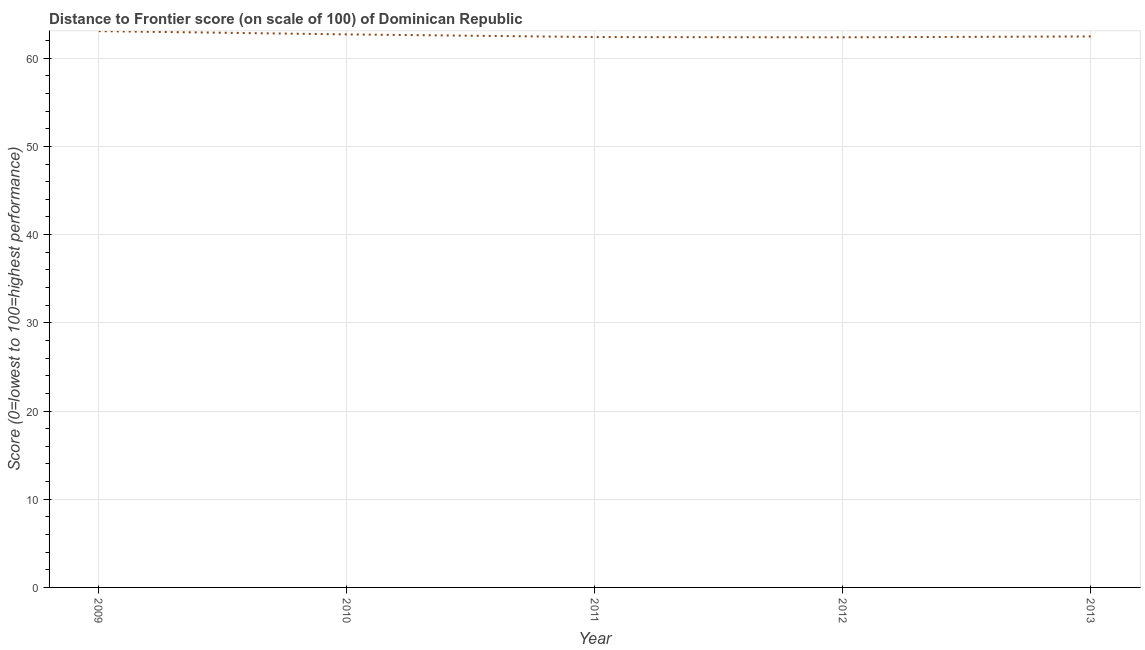What is the distance to frontier score in 2013?
Offer a terse response. 62.47. Across all years, what is the maximum distance to frontier score?
Offer a very short reply. 63.07. Across all years, what is the minimum distance to frontier score?
Offer a very short reply. 62.37. In which year was the distance to frontier score maximum?
Make the answer very short. 2009. What is the sum of the distance to frontier score?
Keep it short and to the point. 313.01. What is the difference between the distance to frontier score in 2010 and 2013?
Provide a short and direct response. 0.23. What is the average distance to frontier score per year?
Offer a very short reply. 62.6. What is the median distance to frontier score?
Ensure brevity in your answer.  62.47. What is the ratio of the distance to frontier score in 2010 to that in 2012?
Your answer should be compact. 1.01. Is the distance to frontier score in 2010 less than that in 2012?
Provide a succinct answer. No. What is the difference between the highest and the second highest distance to frontier score?
Your answer should be very brief. 0.37. Is the sum of the distance to frontier score in 2011 and 2013 greater than the maximum distance to frontier score across all years?
Your answer should be compact. Yes. What is the difference between the highest and the lowest distance to frontier score?
Offer a very short reply. 0.7. How many lines are there?
Give a very brief answer. 1. How many years are there in the graph?
Your answer should be very brief. 5. Are the values on the major ticks of Y-axis written in scientific E-notation?
Your answer should be very brief. No. Does the graph contain any zero values?
Provide a succinct answer. No. What is the title of the graph?
Your answer should be very brief. Distance to Frontier score (on scale of 100) of Dominican Republic. What is the label or title of the Y-axis?
Offer a terse response. Score (0=lowest to 100=highest performance). What is the Score (0=lowest to 100=highest performance) of 2009?
Provide a succinct answer. 63.07. What is the Score (0=lowest to 100=highest performance) of 2010?
Give a very brief answer. 62.7. What is the Score (0=lowest to 100=highest performance) in 2011?
Your answer should be compact. 62.4. What is the Score (0=lowest to 100=highest performance) of 2012?
Offer a terse response. 62.37. What is the Score (0=lowest to 100=highest performance) in 2013?
Offer a very short reply. 62.47. What is the difference between the Score (0=lowest to 100=highest performance) in 2009 and 2010?
Offer a very short reply. 0.37. What is the difference between the Score (0=lowest to 100=highest performance) in 2009 and 2011?
Offer a very short reply. 0.67. What is the difference between the Score (0=lowest to 100=highest performance) in 2009 and 2012?
Provide a short and direct response. 0.7. What is the difference between the Score (0=lowest to 100=highest performance) in 2009 and 2013?
Your answer should be very brief. 0.6. What is the difference between the Score (0=lowest to 100=highest performance) in 2010 and 2012?
Give a very brief answer. 0.33. What is the difference between the Score (0=lowest to 100=highest performance) in 2010 and 2013?
Make the answer very short. 0.23. What is the difference between the Score (0=lowest to 100=highest performance) in 2011 and 2013?
Keep it short and to the point. -0.07. What is the ratio of the Score (0=lowest to 100=highest performance) in 2009 to that in 2010?
Offer a terse response. 1.01. What is the ratio of the Score (0=lowest to 100=highest performance) in 2009 to that in 2012?
Offer a terse response. 1.01. What is the ratio of the Score (0=lowest to 100=highest performance) in 2009 to that in 2013?
Your answer should be compact. 1.01. What is the ratio of the Score (0=lowest to 100=highest performance) in 2011 to that in 2012?
Offer a very short reply. 1. What is the ratio of the Score (0=lowest to 100=highest performance) in 2012 to that in 2013?
Offer a very short reply. 1. 